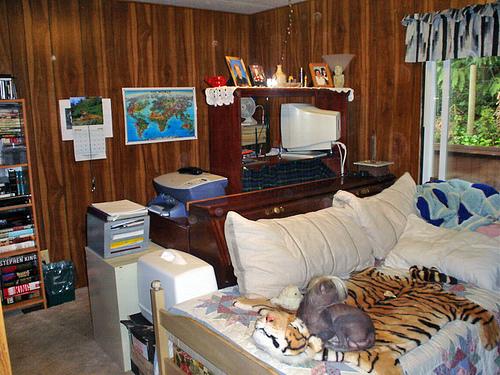Is the bookcase full?
Keep it brief. Yes. What color are the walls?
Keep it brief. Brown. Is there a map of the world on the back wall?
Write a very short answer. Yes. 